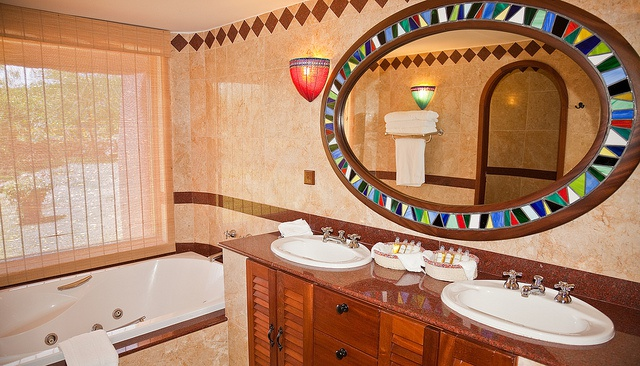Describe the objects in this image and their specific colors. I can see sink in maroon, lightgray, tan, and darkgray tones, sink in maroon, lightgray, tan, and darkgray tones, toothbrush in maroon, ivory, khaki, darkgray, and tan tones, toothbrush in maroon, lightgray, tan, and gray tones, and toothbrush in maroon, tan, darkgray, and orange tones in this image. 